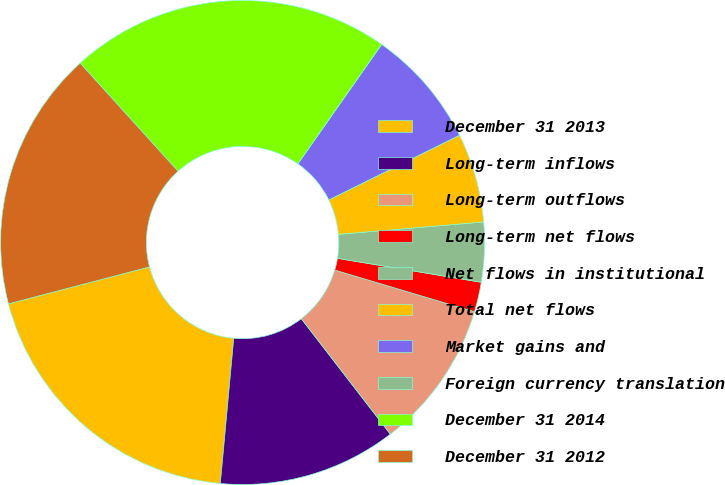Convert chart to OTSL. <chart><loc_0><loc_0><loc_500><loc_500><pie_chart><fcel>December 31 2013<fcel>Long-term inflows<fcel>Long-term outflows<fcel>Long-term net flows<fcel>Net flows in institutional<fcel>Total net flows<fcel>Market gains and<fcel>Foreign currency translation<fcel>December 31 2014<fcel>December 31 2012<nl><fcel>19.46%<fcel>11.92%<fcel>9.93%<fcel>1.99%<fcel>3.98%<fcel>5.96%<fcel>7.95%<fcel>0.0%<fcel>21.45%<fcel>17.37%<nl></chart> 